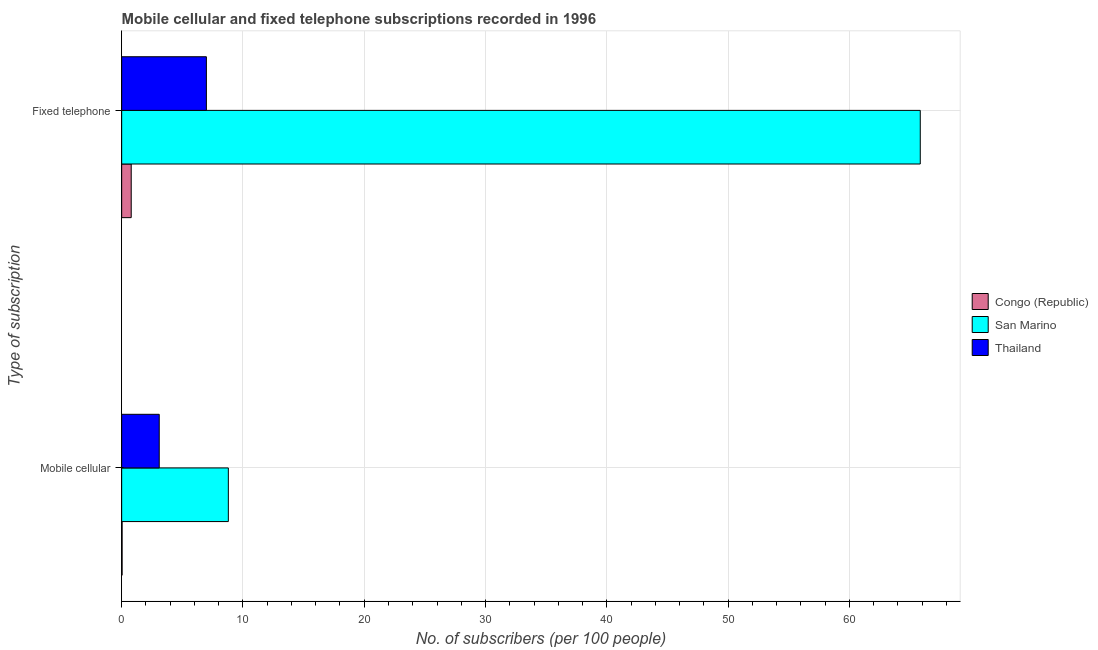How many groups of bars are there?
Keep it short and to the point. 2. Are the number of bars on each tick of the Y-axis equal?
Offer a very short reply. Yes. How many bars are there on the 2nd tick from the top?
Your answer should be compact. 3. What is the label of the 2nd group of bars from the top?
Make the answer very short. Mobile cellular. What is the number of fixed telephone subscribers in Congo (Republic)?
Make the answer very short. 0.79. Across all countries, what is the maximum number of mobile cellular subscribers?
Your answer should be very brief. 8.79. Across all countries, what is the minimum number of mobile cellular subscribers?
Make the answer very short. 0.04. In which country was the number of fixed telephone subscribers maximum?
Offer a terse response. San Marino. In which country was the number of fixed telephone subscribers minimum?
Give a very brief answer. Congo (Republic). What is the total number of mobile cellular subscribers in the graph?
Offer a very short reply. 11.93. What is the difference between the number of fixed telephone subscribers in Congo (Republic) and that in San Marino?
Keep it short and to the point. -65.06. What is the difference between the number of fixed telephone subscribers in Thailand and the number of mobile cellular subscribers in San Marino?
Your answer should be very brief. -1.81. What is the average number of mobile cellular subscribers per country?
Make the answer very short. 3.98. What is the difference between the number of mobile cellular subscribers and number of fixed telephone subscribers in Congo (Republic)?
Offer a very short reply. -0.75. In how many countries, is the number of mobile cellular subscribers greater than 38 ?
Make the answer very short. 0. What is the ratio of the number of mobile cellular subscribers in Congo (Republic) to that in San Marino?
Your answer should be compact. 0. In how many countries, is the number of mobile cellular subscribers greater than the average number of mobile cellular subscribers taken over all countries?
Make the answer very short. 1. What does the 1st bar from the top in Mobile cellular represents?
Provide a succinct answer. Thailand. What does the 2nd bar from the bottom in Fixed telephone represents?
Your answer should be very brief. San Marino. Are all the bars in the graph horizontal?
Give a very brief answer. Yes. How many countries are there in the graph?
Provide a succinct answer. 3. Are the values on the major ticks of X-axis written in scientific E-notation?
Give a very brief answer. No. Does the graph contain grids?
Provide a succinct answer. Yes. How many legend labels are there?
Provide a succinct answer. 3. What is the title of the graph?
Make the answer very short. Mobile cellular and fixed telephone subscriptions recorded in 1996. What is the label or title of the X-axis?
Your answer should be very brief. No. of subscribers (per 100 people). What is the label or title of the Y-axis?
Give a very brief answer. Type of subscription. What is the No. of subscribers (per 100 people) of Congo (Republic) in Mobile cellular?
Ensure brevity in your answer.  0.04. What is the No. of subscribers (per 100 people) in San Marino in Mobile cellular?
Provide a short and direct response. 8.79. What is the No. of subscribers (per 100 people) of Thailand in Mobile cellular?
Offer a very short reply. 3.1. What is the No. of subscribers (per 100 people) of Congo (Republic) in Fixed telephone?
Your answer should be very brief. 0.79. What is the No. of subscribers (per 100 people) in San Marino in Fixed telephone?
Offer a very short reply. 65.84. What is the No. of subscribers (per 100 people) in Thailand in Fixed telephone?
Provide a succinct answer. 6.98. Across all Type of subscription, what is the maximum No. of subscribers (per 100 people) of Congo (Republic)?
Offer a very short reply. 0.79. Across all Type of subscription, what is the maximum No. of subscribers (per 100 people) in San Marino?
Your answer should be very brief. 65.84. Across all Type of subscription, what is the maximum No. of subscribers (per 100 people) of Thailand?
Provide a succinct answer. 6.98. Across all Type of subscription, what is the minimum No. of subscribers (per 100 people) in Congo (Republic)?
Your answer should be compact. 0.04. Across all Type of subscription, what is the minimum No. of subscribers (per 100 people) of San Marino?
Make the answer very short. 8.79. Across all Type of subscription, what is the minimum No. of subscribers (per 100 people) in Thailand?
Your answer should be compact. 3.1. What is the total No. of subscribers (per 100 people) in Congo (Republic) in the graph?
Offer a very short reply. 0.82. What is the total No. of subscribers (per 100 people) in San Marino in the graph?
Provide a short and direct response. 74.64. What is the total No. of subscribers (per 100 people) in Thailand in the graph?
Give a very brief answer. 10.08. What is the difference between the No. of subscribers (per 100 people) of Congo (Republic) in Mobile cellular and that in Fixed telephone?
Keep it short and to the point. -0.75. What is the difference between the No. of subscribers (per 100 people) in San Marino in Mobile cellular and that in Fixed telephone?
Keep it short and to the point. -57.05. What is the difference between the No. of subscribers (per 100 people) of Thailand in Mobile cellular and that in Fixed telephone?
Provide a succinct answer. -3.89. What is the difference between the No. of subscribers (per 100 people) in Congo (Republic) in Mobile cellular and the No. of subscribers (per 100 people) in San Marino in Fixed telephone?
Offer a very short reply. -65.81. What is the difference between the No. of subscribers (per 100 people) in Congo (Republic) in Mobile cellular and the No. of subscribers (per 100 people) in Thailand in Fixed telephone?
Ensure brevity in your answer.  -6.95. What is the difference between the No. of subscribers (per 100 people) in San Marino in Mobile cellular and the No. of subscribers (per 100 people) in Thailand in Fixed telephone?
Provide a succinct answer. 1.81. What is the average No. of subscribers (per 100 people) in Congo (Republic) per Type of subscription?
Offer a very short reply. 0.41. What is the average No. of subscribers (per 100 people) of San Marino per Type of subscription?
Give a very brief answer. 37.32. What is the average No. of subscribers (per 100 people) in Thailand per Type of subscription?
Offer a terse response. 5.04. What is the difference between the No. of subscribers (per 100 people) of Congo (Republic) and No. of subscribers (per 100 people) of San Marino in Mobile cellular?
Your answer should be very brief. -8.76. What is the difference between the No. of subscribers (per 100 people) in Congo (Republic) and No. of subscribers (per 100 people) in Thailand in Mobile cellular?
Offer a very short reply. -3.06. What is the difference between the No. of subscribers (per 100 people) of San Marino and No. of subscribers (per 100 people) of Thailand in Mobile cellular?
Give a very brief answer. 5.7. What is the difference between the No. of subscribers (per 100 people) of Congo (Republic) and No. of subscribers (per 100 people) of San Marino in Fixed telephone?
Keep it short and to the point. -65.06. What is the difference between the No. of subscribers (per 100 people) of Congo (Republic) and No. of subscribers (per 100 people) of Thailand in Fixed telephone?
Your answer should be compact. -6.2. What is the difference between the No. of subscribers (per 100 people) of San Marino and No. of subscribers (per 100 people) of Thailand in Fixed telephone?
Offer a very short reply. 58.86. What is the ratio of the No. of subscribers (per 100 people) of Congo (Republic) in Mobile cellular to that in Fixed telephone?
Your response must be concise. 0.05. What is the ratio of the No. of subscribers (per 100 people) of San Marino in Mobile cellular to that in Fixed telephone?
Offer a terse response. 0.13. What is the ratio of the No. of subscribers (per 100 people) in Thailand in Mobile cellular to that in Fixed telephone?
Offer a very short reply. 0.44. What is the difference between the highest and the second highest No. of subscribers (per 100 people) in Congo (Republic)?
Give a very brief answer. 0.75. What is the difference between the highest and the second highest No. of subscribers (per 100 people) in San Marino?
Make the answer very short. 57.05. What is the difference between the highest and the second highest No. of subscribers (per 100 people) of Thailand?
Keep it short and to the point. 3.89. What is the difference between the highest and the lowest No. of subscribers (per 100 people) in Congo (Republic)?
Provide a succinct answer. 0.75. What is the difference between the highest and the lowest No. of subscribers (per 100 people) of San Marino?
Provide a short and direct response. 57.05. What is the difference between the highest and the lowest No. of subscribers (per 100 people) of Thailand?
Make the answer very short. 3.89. 